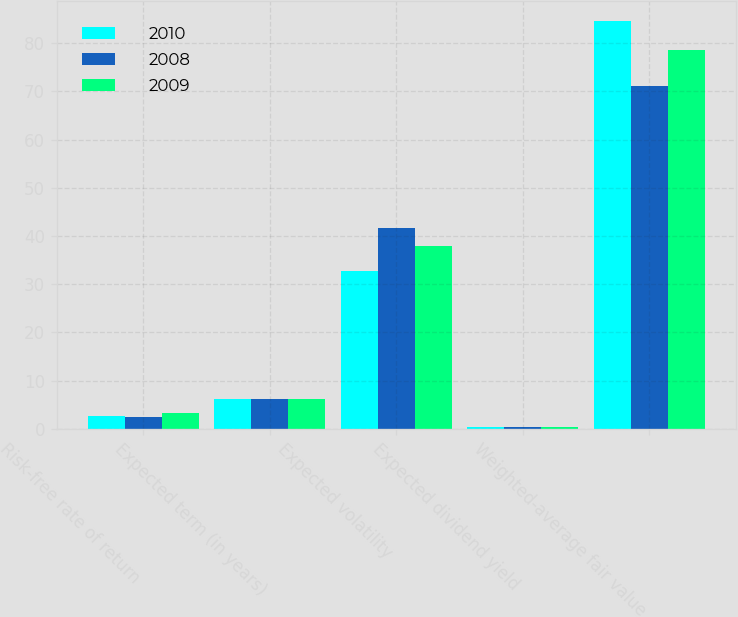Convert chart to OTSL. <chart><loc_0><loc_0><loc_500><loc_500><stacked_bar_chart><ecel><fcel>Risk-free rate of return<fcel>Expected term (in years)<fcel>Expected volatility<fcel>Expected dividend yield<fcel>Weighted-average fair value<nl><fcel>2010<fcel>2.7<fcel>6.25<fcel>32.7<fcel>0.3<fcel>84.62<nl><fcel>2008<fcel>2.5<fcel>6.17<fcel>41.7<fcel>0.4<fcel>71.03<nl><fcel>2009<fcel>3.2<fcel>6.25<fcel>37.9<fcel>0.3<fcel>78.54<nl></chart> 